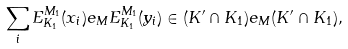Convert formula to latex. <formula><loc_0><loc_0><loc_500><loc_500>\sum _ { i } E ^ { M _ { 1 } } _ { K _ { 1 } } ( x _ { i } ) e _ { M } E ^ { M _ { 1 } } _ { K _ { 1 } } ( y _ { i } ) \in ( K ^ { \prime } \cap K _ { 1 } ) e _ { M } ( K ^ { \prime } \cap K _ { 1 } ) ,</formula> 